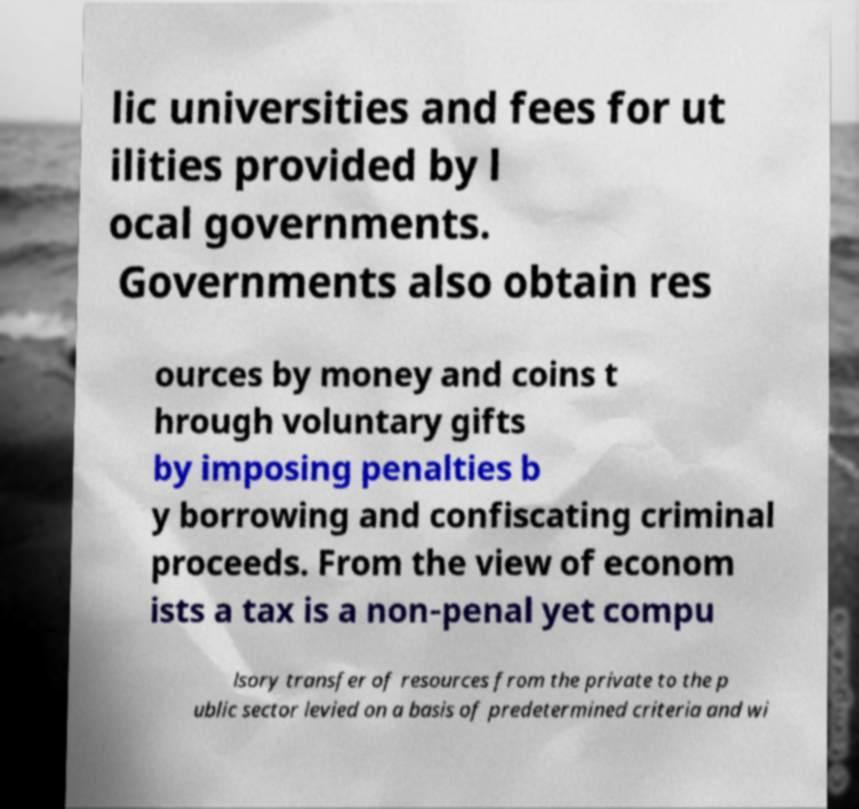Can you read and provide the text displayed in the image?This photo seems to have some interesting text. Can you extract and type it out for me? lic universities and fees for ut ilities provided by l ocal governments. Governments also obtain res ources by money and coins t hrough voluntary gifts by imposing penalties b y borrowing and confiscating criminal proceeds. From the view of econom ists a tax is a non-penal yet compu lsory transfer of resources from the private to the p ublic sector levied on a basis of predetermined criteria and wi 